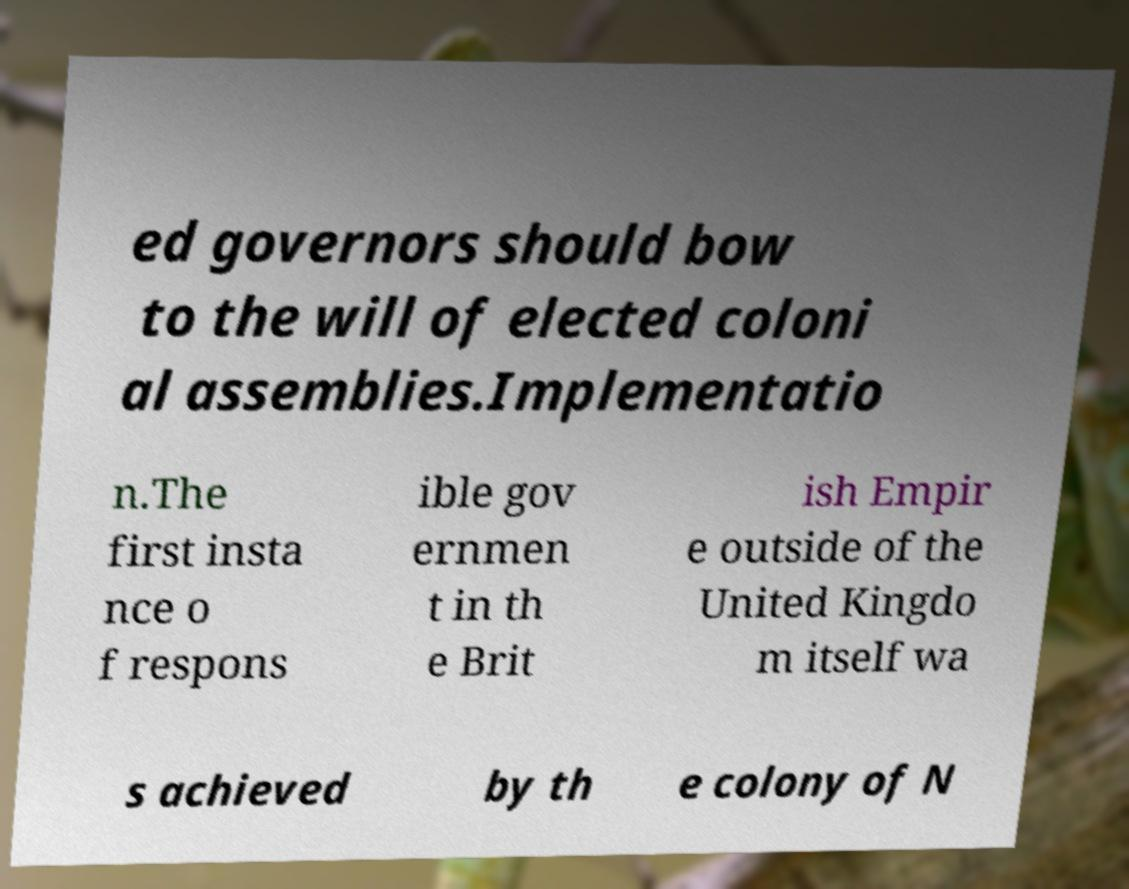There's text embedded in this image that I need extracted. Can you transcribe it verbatim? ed governors should bow to the will of elected coloni al assemblies.Implementatio n.The first insta nce o f respons ible gov ernmen t in th e Brit ish Empir e outside of the United Kingdo m itself wa s achieved by th e colony of N 